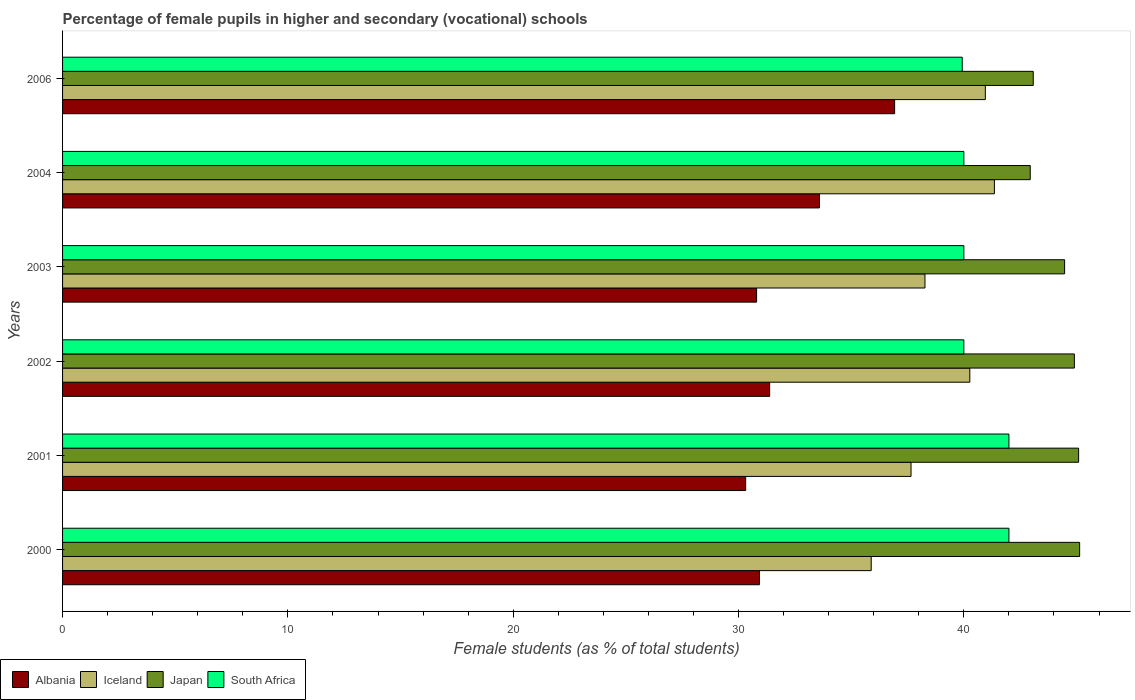How many groups of bars are there?
Ensure brevity in your answer.  6. How many bars are there on the 6th tick from the bottom?
Your response must be concise. 4. In how many cases, is the number of bars for a given year not equal to the number of legend labels?
Your answer should be very brief. 0. What is the percentage of female pupils in higher and secondary schools in Albania in 2002?
Your response must be concise. 31.38. Across all years, what is the maximum percentage of female pupils in higher and secondary schools in Albania?
Give a very brief answer. 36.93. Across all years, what is the minimum percentage of female pupils in higher and secondary schools in Iceland?
Ensure brevity in your answer.  35.89. What is the total percentage of female pupils in higher and secondary schools in Albania in the graph?
Provide a short and direct response. 193.95. What is the difference between the percentage of female pupils in higher and secondary schools in Albania in 2001 and that in 2002?
Keep it short and to the point. -1.06. What is the difference between the percentage of female pupils in higher and secondary schools in Albania in 2000 and the percentage of female pupils in higher and secondary schools in South Africa in 2002?
Your response must be concise. -9.07. What is the average percentage of female pupils in higher and secondary schools in Japan per year?
Make the answer very short. 44.27. In the year 2000, what is the difference between the percentage of female pupils in higher and secondary schools in South Africa and percentage of female pupils in higher and secondary schools in Iceland?
Provide a short and direct response. 6.11. In how many years, is the percentage of female pupils in higher and secondary schools in Iceland greater than 14 %?
Your answer should be very brief. 6. What is the ratio of the percentage of female pupils in higher and secondary schools in Albania in 2000 to that in 2004?
Ensure brevity in your answer.  0.92. What is the difference between the highest and the second highest percentage of female pupils in higher and secondary schools in Iceland?
Ensure brevity in your answer.  0.4. What is the difference between the highest and the lowest percentage of female pupils in higher and secondary schools in Japan?
Your answer should be very brief. 2.19. In how many years, is the percentage of female pupils in higher and secondary schools in Japan greater than the average percentage of female pupils in higher and secondary schools in Japan taken over all years?
Give a very brief answer. 4. Is it the case that in every year, the sum of the percentage of female pupils in higher and secondary schools in Japan and percentage of female pupils in higher and secondary schools in Iceland is greater than the sum of percentage of female pupils in higher and secondary schools in Albania and percentage of female pupils in higher and secondary schools in South Africa?
Your response must be concise. Yes. What does the 4th bar from the top in 2004 represents?
Keep it short and to the point. Albania. What does the 2nd bar from the bottom in 2002 represents?
Make the answer very short. Iceland. Is it the case that in every year, the sum of the percentage of female pupils in higher and secondary schools in Japan and percentage of female pupils in higher and secondary schools in Albania is greater than the percentage of female pupils in higher and secondary schools in Iceland?
Provide a short and direct response. Yes. Are all the bars in the graph horizontal?
Your answer should be compact. Yes. Where does the legend appear in the graph?
Ensure brevity in your answer.  Bottom left. How are the legend labels stacked?
Provide a succinct answer. Horizontal. What is the title of the graph?
Provide a succinct answer. Percentage of female pupils in higher and secondary (vocational) schools. What is the label or title of the X-axis?
Offer a very short reply. Female students (as % of total students). What is the Female students (as % of total students) of Albania in 2000?
Your answer should be compact. 30.93. What is the Female students (as % of total students) of Iceland in 2000?
Your response must be concise. 35.89. What is the Female students (as % of total students) in Japan in 2000?
Your answer should be very brief. 45.14. What is the Female students (as % of total students) of South Africa in 2000?
Keep it short and to the point. 42. What is the Female students (as % of total students) in Albania in 2001?
Offer a very short reply. 30.32. What is the Female students (as % of total students) of Iceland in 2001?
Provide a short and direct response. 37.66. What is the Female students (as % of total students) of Japan in 2001?
Make the answer very short. 45.09. What is the Female students (as % of total students) in South Africa in 2001?
Ensure brevity in your answer.  42. What is the Female students (as % of total students) in Albania in 2002?
Offer a terse response. 31.38. What is the Female students (as % of total students) in Iceland in 2002?
Your response must be concise. 40.26. What is the Female students (as % of total students) of Japan in 2002?
Offer a very short reply. 44.9. What is the Female students (as % of total students) of South Africa in 2002?
Ensure brevity in your answer.  40. What is the Female students (as % of total students) in Albania in 2003?
Your answer should be compact. 30.8. What is the Female students (as % of total students) of Iceland in 2003?
Provide a short and direct response. 38.27. What is the Female students (as % of total students) in Japan in 2003?
Provide a short and direct response. 44.47. What is the Female students (as % of total students) of South Africa in 2003?
Your answer should be very brief. 40. What is the Female students (as % of total students) in Albania in 2004?
Give a very brief answer. 33.59. What is the Female students (as % of total students) in Iceland in 2004?
Your response must be concise. 41.36. What is the Female students (as % of total students) in Japan in 2004?
Your answer should be compact. 42.95. What is the Female students (as % of total students) in South Africa in 2004?
Offer a terse response. 40. What is the Female students (as % of total students) of Albania in 2006?
Ensure brevity in your answer.  36.93. What is the Female students (as % of total students) of Iceland in 2006?
Your answer should be very brief. 40.95. What is the Female students (as % of total students) of Japan in 2006?
Offer a very short reply. 43.08. What is the Female students (as % of total students) in South Africa in 2006?
Give a very brief answer. 39.93. Across all years, what is the maximum Female students (as % of total students) of Albania?
Your answer should be very brief. 36.93. Across all years, what is the maximum Female students (as % of total students) of Iceland?
Offer a very short reply. 41.36. Across all years, what is the maximum Female students (as % of total students) of Japan?
Your response must be concise. 45.14. Across all years, what is the maximum Female students (as % of total students) of South Africa?
Offer a terse response. 42. Across all years, what is the minimum Female students (as % of total students) of Albania?
Keep it short and to the point. 30.32. Across all years, what is the minimum Female students (as % of total students) of Iceland?
Ensure brevity in your answer.  35.89. Across all years, what is the minimum Female students (as % of total students) in Japan?
Offer a very short reply. 42.95. Across all years, what is the minimum Female students (as % of total students) of South Africa?
Keep it short and to the point. 39.93. What is the total Female students (as % of total students) of Albania in the graph?
Offer a very short reply. 193.95. What is the total Female students (as % of total students) in Iceland in the graph?
Offer a terse response. 234.39. What is the total Female students (as % of total students) in Japan in the graph?
Give a very brief answer. 265.64. What is the total Female students (as % of total students) of South Africa in the graph?
Your response must be concise. 243.93. What is the difference between the Female students (as % of total students) of Albania in 2000 and that in 2001?
Give a very brief answer. 0.61. What is the difference between the Female students (as % of total students) in Iceland in 2000 and that in 2001?
Your response must be concise. -1.77. What is the difference between the Female students (as % of total students) in Japan in 2000 and that in 2001?
Your answer should be compact. 0.04. What is the difference between the Female students (as % of total students) of Albania in 2000 and that in 2002?
Your response must be concise. -0.45. What is the difference between the Female students (as % of total students) in Iceland in 2000 and that in 2002?
Provide a short and direct response. -4.38. What is the difference between the Female students (as % of total students) of Japan in 2000 and that in 2002?
Your answer should be compact. 0.23. What is the difference between the Female students (as % of total students) in South Africa in 2000 and that in 2002?
Ensure brevity in your answer.  2. What is the difference between the Female students (as % of total students) of Albania in 2000 and that in 2003?
Offer a terse response. 0.13. What is the difference between the Female students (as % of total students) of Iceland in 2000 and that in 2003?
Make the answer very short. -2.39. What is the difference between the Female students (as % of total students) of Japan in 2000 and that in 2003?
Keep it short and to the point. 0.67. What is the difference between the Female students (as % of total students) in South Africa in 2000 and that in 2003?
Provide a succinct answer. 2. What is the difference between the Female students (as % of total students) in Albania in 2000 and that in 2004?
Your answer should be compact. -2.66. What is the difference between the Female students (as % of total students) of Iceland in 2000 and that in 2004?
Make the answer very short. -5.47. What is the difference between the Female students (as % of total students) of Japan in 2000 and that in 2004?
Your response must be concise. 2.19. What is the difference between the Female students (as % of total students) of South Africa in 2000 and that in 2004?
Your answer should be compact. 2. What is the difference between the Female students (as % of total students) in Albania in 2000 and that in 2006?
Keep it short and to the point. -6. What is the difference between the Female students (as % of total students) of Iceland in 2000 and that in 2006?
Provide a succinct answer. -5.07. What is the difference between the Female students (as % of total students) of Japan in 2000 and that in 2006?
Provide a succinct answer. 2.06. What is the difference between the Female students (as % of total students) of South Africa in 2000 and that in 2006?
Offer a very short reply. 2.07. What is the difference between the Female students (as % of total students) of Albania in 2001 and that in 2002?
Your response must be concise. -1.06. What is the difference between the Female students (as % of total students) of Iceland in 2001 and that in 2002?
Give a very brief answer. -2.61. What is the difference between the Female students (as % of total students) in Japan in 2001 and that in 2002?
Provide a short and direct response. 0.19. What is the difference between the Female students (as % of total students) of South Africa in 2001 and that in 2002?
Your response must be concise. 2. What is the difference between the Female students (as % of total students) in Albania in 2001 and that in 2003?
Offer a terse response. -0.49. What is the difference between the Female students (as % of total students) in Iceland in 2001 and that in 2003?
Ensure brevity in your answer.  -0.62. What is the difference between the Female students (as % of total students) of Japan in 2001 and that in 2003?
Make the answer very short. 0.62. What is the difference between the Female students (as % of total students) in South Africa in 2001 and that in 2003?
Offer a terse response. 2. What is the difference between the Female students (as % of total students) in Albania in 2001 and that in 2004?
Provide a short and direct response. -3.28. What is the difference between the Female students (as % of total students) of Iceland in 2001 and that in 2004?
Make the answer very short. -3.7. What is the difference between the Female students (as % of total students) of Japan in 2001 and that in 2004?
Your response must be concise. 2.15. What is the difference between the Female students (as % of total students) in South Africa in 2001 and that in 2004?
Provide a succinct answer. 2. What is the difference between the Female students (as % of total students) in Albania in 2001 and that in 2006?
Offer a very short reply. -6.61. What is the difference between the Female students (as % of total students) of Iceland in 2001 and that in 2006?
Offer a very short reply. -3.3. What is the difference between the Female students (as % of total students) in Japan in 2001 and that in 2006?
Keep it short and to the point. 2.01. What is the difference between the Female students (as % of total students) of South Africa in 2001 and that in 2006?
Ensure brevity in your answer.  2.07. What is the difference between the Female students (as % of total students) in Albania in 2002 and that in 2003?
Your response must be concise. 0.58. What is the difference between the Female students (as % of total students) of Iceland in 2002 and that in 2003?
Your answer should be compact. 1.99. What is the difference between the Female students (as % of total students) of Japan in 2002 and that in 2003?
Offer a terse response. 0.43. What is the difference between the Female students (as % of total students) in South Africa in 2002 and that in 2003?
Offer a terse response. -0. What is the difference between the Female students (as % of total students) of Albania in 2002 and that in 2004?
Keep it short and to the point. -2.21. What is the difference between the Female students (as % of total students) in Iceland in 2002 and that in 2004?
Your response must be concise. -1.09. What is the difference between the Female students (as % of total students) of Japan in 2002 and that in 2004?
Keep it short and to the point. 1.96. What is the difference between the Female students (as % of total students) in South Africa in 2002 and that in 2004?
Your answer should be compact. -0. What is the difference between the Female students (as % of total students) of Albania in 2002 and that in 2006?
Provide a succinct answer. -5.55. What is the difference between the Female students (as % of total students) in Iceland in 2002 and that in 2006?
Ensure brevity in your answer.  -0.69. What is the difference between the Female students (as % of total students) in Japan in 2002 and that in 2006?
Your response must be concise. 1.82. What is the difference between the Female students (as % of total students) of South Africa in 2002 and that in 2006?
Give a very brief answer. 0.07. What is the difference between the Female students (as % of total students) in Albania in 2003 and that in 2004?
Your response must be concise. -2.79. What is the difference between the Female students (as % of total students) of Iceland in 2003 and that in 2004?
Your response must be concise. -3.08. What is the difference between the Female students (as % of total students) in Japan in 2003 and that in 2004?
Offer a very short reply. 1.52. What is the difference between the Female students (as % of total students) of Albania in 2003 and that in 2006?
Provide a short and direct response. -6.13. What is the difference between the Female students (as % of total students) of Iceland in 2003 and that in 2006?
Offer a very short reply. -2.68. What is the difference between the Female students (as % of total students) of Japan in 2003 and that in 2006?
Offer a terse response. 1.39. What is the difference between the Female students (as % of total students) in South Africa in 2003 and that in 2006?
Provide a succinct answer. 0.07. What is the difference between the Female students (as % of total students) of Albania in 2004 and that in 2006?
Offer a very short reply. -3.33. What is the difference between the Female students (as % of total students) of Iceland in 2004 and that in 2006?
Provide a short and direct response. 0.4. What is the difference between the Female students (as % of total students) of Japan in 2004 and that in 2006?
Ensure brevity in your answer.  -0.13. What is the difference between the Female students (as % of total students) in South Africa in 2004 and that in 2006?
Keep it short and to the point. 0.07. What is the difference between the Female students (as % of total students) of Albania in 2000 and the Female students (as % of total students) of Iceland in 2001?
Keep it short and to the point. -6.73. What is the difference between the Female students (as % of total students) of Albania in 2000 and the Female students (as % of total students) of Japan in 2001?
Make the answer very short. -14.17. What is the difference between the Female students (as % of total students) in Albania in 2000 and the Female students (as % of total students) in South Africa in 2001?
Provide a succinct answer. -11.07. What is the difference between the Female students (as % of total students) in Iceland in 2000 and the Female students (as % of total students) in Japan in 2001?
Offer a terse response. -9.21. What is the difference between the Female students (as % of total students) of Iceland in 2000 and the Female students (as % of total students) of South Africa in 2001?
Keep it short and to the point. -6.11. What is the difference between the Female students (as % of total students) of Japan in 2000 and the Female students (as % of total students) of South Africa in 2001?
Provide a succinct answer. 3.14. What is the difference between the Female students (as % of total students) of Albania in 2000 and the Female students (as % of total students) of Iceland in 2002?
Keep it short and to the point. -9.34. What is the difference between the Female students (as % of total students) in Albania in 2000 and the Female students (as % of total students) in Japan in 2002?
Your response must be concise. -13.98. What is the difference between the Female students (as % of total students) in Albania in 2000 and the Female students (as % of total students) in South Africa in 2002?
Make the answer very short. -9.07. What is the difference between the Female students (as % of total students) in Iceland in 2000 and the Female students (as % of total students) in Japan in 2002?
Offer a terse response. -9.02. What is the difference between the Female students (as % of total students) in Iceland in 2000 and the Female students (as % of total students) in South Africa in 2002?
Give a very brief answer. -4.11. What is the difference between the Female students (as % of total students) of Japan in 2000 and the Female students (as % of total students) of South Africa in 2002?
Keep it short and to the point. 5.14. What is the difference between the Female students (as % of total students) of Albania in 2000 and the Female students (as % of total students) of Iceland in 2003?
Give a very brief answer. -7.35. What is the difference between the Female students (as % of total students) in Albania in 2000 and the Female students (as % of total students) in Japan in 2003?
Give a very brief answer. -13.54. What is the difference between the Female students (as % of total students) in Albania in 2000 and the Female students (as % of total students) in South Africa in 2003?
Offer a very short reply. -9.07. What is the difference between the Female students (as % of total students) of Iceland in 2000 and the Female students (as % of total students) of Japan in 2003?
Provide a short and direct response. -8.58. What is the difference between the Female students (as % of total students) in Iceland in 2000 and the Female students (as % of total students) in South Africa in 2003?
Give a very brief answer. -4.11. What is the difference between the Female students (as % of total students) in Japan in 2000 and the Female students (as % of total students) in South Africa in 2003?
Keep it short and to the point. 5.14. What is the difference between the Female students (as % of total students) in Albania in 2000 and the Female students (as % of total students) in Iceland in 2004?
Make the answer very short. -10.43. What is the difference between the Female students (as % of total students) in Albania in 2000 and the Female students (as % of total students) in Japan in 2004?
Offer a terse response. -12.02. What is the difference between the Female students (as % of total students) in Albania in 2000 and the Female students (as % of total students) in South Africa in 2004?
Your answer should be compact. -9.07. What is the difference between the Female students (as % of total students) of Iceland in 2000 and the Female students (as % of total students) of Japan in 2004?
Your response must be concise. -7.06. What is the difference between the Female students (as % of total students) in Iceland in 2000 and the Female students (as % of total students) in South Africa in 2004?
Ensure brevity in your answer.  -4.11. What is the difference between the Female students (as % of total students) of Japan in 2000 and the Female students (as % of total students) of South Africa in 2004?
Offer a very short reply. 5.14. What is the difference between the Female students (as % of total students) in Albania in 2000 and the Female students (as % of total students) in Iceland in 2006?
Your response must be concise. -10.02. What is the difference between the Female students (as % of total students) of Albania in 2000 and the Female students (as % of total students) of Japan in 2006?
Offer a terse response. -12.15. What is the difference between the Female students (as % of total students) of Albania in 2000 and the Female students (as % of total students) of South Africa in 2006?
Your response must be concise. -9. What is the difference between the Female students (as % of total students) of Iceland in 2000 and the Female students (as % of total students) of Japan in 2006?
Provide a short and direct response. -7.19. What is the difference between the Female students (as % of total students) of Iceland in 2000 and the Female students (as % of total students) of South Africa in 2006?
Offer a terse response. -4.04. What is the difference between the Female students (as % of total students) in Japan in 2000 and the Female students (as % of total students) in South Africa in 2006?
Your answer should be very brief. 5.21. What is the difference between the Female students (as % of total students) of Albania in 2001 and the Female students (as % of total students) of Iceland in 2002?
Offer a very short reply. -9.95. What is the difference between the Female students (as % of total students) of Albania in 2001 and the Female students (as % of total students) of Japan in 2002?
Make the answer very short. -14.59. What is the difference between the Female students (as % of total students) of Albania in 2001 and the Female students (as % of total students) of South Africa in 2002?
Offer a very short reply. -9.68. What is the difference between the Female students (as % of total students) of Iceland in 2001 and the Female students (as % of total students) of Japan in 2002?
Ensure brevity in your answer.  -7.25. What is the difference between the Female students (as % of total students) in Iceland in 2001 and the Female students (as % of total students) in South Africa in 2002?
Keep it short and to the point. -2.34. What is the difference between the Female students (as % of total students) in Japan in 2001 and the Female students (as % of total students) in South Africa in 2002?
Your answer should be very brief. 5.09. What is the difference between the Female students (as % of total students) in Albania in 2001 and the Female students (as % of total students) in Iceland in 2003?
Your response must be concise. -7.96. What is the difference between the Female students (as % of total students) of Albania in 2001 and the Female students (as % of total students) of Japan in 2003?
Your answer should be very brief. -14.15. What is the difference between the Female students (as % of total students) of Albania in 2001 and the Female students (as % of total students) of South Africa in 2003?
Keep it short and to the point. -9.68. What is the difference between the Female students (as % of total students) of Iceland in 2001 and the Female students (as % of total students) of Japan in 2003?
Your answer should be compact. -6.82. What is the difference between the Female students (as % of total students) of Iceland in 2001 and the Female students (as % of total students) of South Africa in 2003?
Make the answer very short. -2.34. What is the difference between the Female students (as % of total students) of Japan in 2001 and the Female students (as % of total students) of South Africa in 2003?
Offer a very short reply. 5.09. What is the difference between the Female students (as % of total students) in Albania in 2001 and the Female students (as % of total students) in Iceland in 2004?
Offer a very short reply. -11.04. What is the difference between the Female students (as % of total students) of Albania in 2001 and the Female students (as % of total students) of Japan in 2004?
Give a very brief answer. -12.63. What is the difference between the Female students (as % of total students) of Albania in 2001 and the Female students (as % of total students) of South Africa in 2004?
Your answer should be compact. -9.68. What is the difference between the Female students (as % of total students) of Iceland in 2001 and the Female students (as % of total students) of Japan in 2004?
Provide a short and direct response. -5.29. What is the difference between the Female students (as % of total students) of Iceland in 2001 and the Female students (as % of total students) of South Africa in 2004?
Keep it short and to the point. -2.34. What is the difference between the Female students (as % of total students) in Japan in 2001 and the Female students (as % of total students) in South Africa in 2004?
Ensure brevity in your answer.  5.09. What is the difference between the Female students (as % of total students) of Albania in 2001 and the Female students (as % of total students) of Iceland in 2006?
Make the answer very short. -10.64. What is the difference between the Female students (as % of total students) in Albania in 2001 and the Female students (as % of total students) in Japan in 2006?
Provide a succinct answer. -12.76. What is the difference between the Female students (as % of total students) of Albania in 2001 and the Female students (as % of total students) of South Africa in 2006?
Your answer should be very brief. -9.61. What is the difference between the Female students (as % of total students) in Iceland in 2001 and the Female students (as % of total students) in Japan in 2006?
Your answer should be very brief. -5.42. What is the difference between the Female students (as % of total students) of Iceland in 2001 and the Female students (as % of total students) of South Africa in 2006?
Give a very brief answer. -2.27. What is the difference between the Female students (as % of total students) in Japan in 2001 and the Female students (as % of total students) in South Africa in 2006?
Give a very brief answer. 5.17. What is the difference between the Female students (as % of total students) in Albania in 2002 and the Female students (as % of total students) in Iceland in 2003?
Keep it short and to the point. -6.89. What is the difference between the Female students (as % of total students) of Albania in 2002 and the Female students (as % of total students) of Japan in 2003?
Provide a succinct answer. -13.09. What is the difference between the Female students (as % of total students) in Albania in 2002 and the Female students (as % of total students) in South Africa in 2003?
Your response must be concise. -8.62. What is the difference between the Female students (as % of total students) of Iceland in 2002 and the Female students (as % of total students) of Japan in 2003?
Provide a short and direct response. -4.21. What is the difference between the Female students (as % of total students) of Iceland in 2002 and the Female students (as % of total students) of South Africa in 2003?
Offer a very short reply. 0.26. What is the difference between the Female students (as % of total students) of Japan in 2002 and the Female students (as % of total students) of South Africa in 2003?
Ensure brevity in your answer.  4.9. What is the difference between the Female students (as % of total students) of Albania in 2002 and the Female students (as % of total students) of Iceland in 2004?
Offer a very short reply. -9.97. What is the difference between the Female students (as % of total students) in Albania in 2002 and the Female students (as % of total students) in Japan in 2004?
Keep it short and to the point. -11.57. What is the difference between the Female students (as % of total students) of Albania in 2002 and the Female students (as % of total students) of South Africa in 2004?
Your response must be concise. -8.62. What is the difference between the Female students (as % of total students) in Iceland in 2002 and the Female students (as % of total students) in Japan in 2004?
Offer a very short reply. -2.68. What is the difference between the Female students (as % of total students) in Iceland in 2002 and the Female students (as % of total students) in South Africa in 2004?
Ensure brevity in your answer.  0.26. What is the difference between the Female students (as % of total students) of Japan in 2002 and the Female students (as % of total students) of South Africa in 2004?
Provide a succinct answer. 4.9. What is the difference between the Female students (as % of total students) of Albania in 2002 and the Female students (as % of total students) of Iceland in 2006?
Your answer should be compact. -9.57. What is the difference between the Female students (as % of total students) in Albania in 2002 and the Female students (as % of total students) in Japan in 2006?
Your answer should be very brief. -11.7. What is the difference between the Female students (as % of total students) in Albania in 2002 and the Female students (as % of total students) in South Africa in 2006?
Your response must be concise. -8.55. What is the difference between the Female students (as % of total students) of Iceland in 2002 and the Female students (as % of total students) of Japan in 2006?
Provide a short and direct response. -2.82. What is the difference between the Female students (as % of total students) in Iceland in 2002 and the Female students (as % of total students) in South Africa in 2006?
Provide a short and direct response. 0.34. What is the difference between the Female students (as % of total students) in Japan in 2002 and the Female students (as % of total students) in South Africa in 2006?
Your answer should be very brief. 4.98. What is the difference between the Female students (as % of total students) in Albania in 2003 and the Female students (as % of total students) in Iceland in 2004?
Provide a short and direct response. -10.55. What is the difference between the Female students (as % of total students) in Albania in 2003 and the Female students (as % of total students) in Japan in 2004?
Make the answer very short. -12.15. What is the difference between the Female students (as % of total students) of Albania in 2003 and the Female students (as % of total students) of South Africa in 2004?
Offer a very short reply. -9.2. What is the difference between the Female students (as % of total students) of Iceland in 2003 and the Female students (as % of total students) of Japan in 2004?
Offer a terse response. -4.67. What is the difference between the Female students (as % of total students) of Iceland in 2003 and the Female students (as % of total students) of South Africa in 2004?
Your answer should be very brief. -1.73. What is the difference between the Female students (as % of total students) of Japan in 2003 and the Female students (as % of total students) of South Africa in 2004?
Offer a very short reply. 4.47. What is the difference between the Female students (as % of total students) in Albania in 2003 and the Female students (as % of total students) in Iceland in 2006?
Ensure brevity in your answer.  -10.15. What is the difference between the Female students (as % of total students) in Albania in 2003 and the Female students (as % of total students) in Japan in 2006?
Provide a short and direct response. -12.28. What is the difference between the Female students (as % of total students) in Albania in 2003 and the Female students (as % of total students) in South Africa in 2006?
Your response must be concise. -9.13. What is the difference between the Female students (as % of total students) of Iceland in 2003 and the Female students (as % of total students) of Japan in 2006?
Offer a terse response. -4.81. What is the difference between the Female students (as % of total students) of Iceland in 2003 and the Female students (as % of total students) of South Africa in 2006?
Offer a very short reply. -1.65. What is the difference between the Female students (as % of total students) in Japan in 2003 and the Female students (as % of total students) in South Africa in 2006?
Make the answer very short. 4.54. What is the difference between the Female students (as % of total students) of Albania in 2004 and the Female students (as % of total students) of Iceland in 2006?
Keep it short and to the point. -7.36. What is the difference between the Female students (as % of total students) in Albania in 2004 and the Female students (as % of total students) in Japan in 2006?
Keep it short and to the point. -9.49. What is the difference between the Female students (as % of total students) of Albania in 2004 and the Female students (as % of total students) of South Africa in 2006?
Ensure brevity in your answer.  -6.34. What is the difference between the Female students (as % of total students) of Iceland in 2004 and the Female students (as % of total students) of Japan in 2006?
Ensure brevity in your answer.  -1.72. What is the difference between the Female students (as % of total students) in Iceland in 2004 and the Female students (as % of total students) in South Africa in 2006?
Your response must be concise. 1.43. What is the difference between the Female students (as % of total students) of Japan in 2004 and the Female students (as % of total students) of South Africa in 2006?
Your answer should be very brief. 3.02. What is the average Female students (as % of total students) of Albania per year?
Provide a succinct answer. 32.32. What is the average Female students (as % of total students) in Iceland per year?
Keep it short and to the point. 39.07. What is the average Female students (as % of total students) in Japan per year?
Make the answer very short. 44.27. What is the average Female students (as % of total students) in South Africa per year?
Your answer should be very brief. 40.65. In the year 2000, what is the difference between the Female students (as % of total students) in Albania and Female students (as % of total students) in Iceland?
Your response must be concise. -4.96. In the year 2000, what is the difference between the Female students (as % of total students) of Albania and Female students (as % of total students) of Japan?
Provide a succinct answer. -14.21. In the year 2000, what is the difference between the Female students (as % of total students) of Albania and Female students (as % of total students) of South Africa?
Offer a very short reply. -11.07. In the year 2000, what is the difference between the Female students (as % of total students) in Iceland and Female students (as % of total students) in Japan?
Provide a short and direct response. -9.25. In the year 2000, what is the difference between the Female students (as % of total students) of Iceland and Female students (as % of total students) of South Africa?
Your response must be concise. -6.11. In the year 2000, what is the difference between the Female students (as % of total students) of Japan and Female students (as % of total students) of South Africa?
Provide a short and direct response. 3.14. In the year 2001, what is the difference between the Female students (as % of total students) in Albania and Female students (as % of total students) in Iceland?
Your response must be concise. -7.34. In the year 2001, what is the difference between the Female students (as % of total students) of Albania and Female students (as % of total students) of Japan?
Ensure brevity in your answer.  -14.78. In the year 2001, what is the difference between the Female students (as % of total students) in Albania and Female students (as % of total students) in South Africa?
Provide a succinct answer. -11.68. In the year 2001, what is the difference between the Female students (as % of total students) of Iceland and Female students (as % of total students) of Japan?
Keep it short and to the point. -7.44. In the year 2001, what is the difference between the Female students (as % of total students) of Iceland and Female students (as % of total students) of South Africa?
Provide a succinct answer. -4.34. In the year 2001, what is the difference between the Female students (as % of total students) of Japan and Female students (as % of total students) of South Africa?
Provide a short and direct response. 3.09. In the year 2002, what is the difference between the Female students (as % of total students) in Albania and Female students (as % of total students) in Iceland?
Make the answer very short. -8.88. In the year 2002, what is the difference between the Female students (as % of total students) in Albania and Female students (as % of total students) in Japan?
Provide a succinct answer. -13.52. In the year 2002, what is the difference between the Female students (as % of total students) of Albania and Female students (as % of total students) of South Africa?
Make the answer very short. -8.62. In the year 2002, what is the difference between the Female students (as % of total students) in Iceland and Female students (as % of total students) in Japan?
Give a very brief answer. -4.64. In the year 2002, what is the difference between the Female students (as % of total students) of Iceland and Female students (as % of total students) of South Africa?
Provide a short and direct response. 0.26. In the year 2002, what is the difference between the Female students (as % of total students) in Japan and Female students (as % of total students) in South Africa?
Make the answer very short. 4.9. In the year 2003, what is the difference between the Female students (as % of total students) of Albania and Female students (as % of total students) of Iceland?
Offer a terse response. -7.47. In the year 2003, what is the difference between the Female students (as % of total students) in Albania and Female students (as % of total students) in Japan?
Offer a terse response. -13.67. In the year 2003, what is the difference between the Female students (as % of total students) in Albania and Female students (as % of total students) in South Africa?
Provide a short and direct response. -9.2. In the year 2003, what is the difference between the Female students (as % of total students) of Iceland and Female students (as % of total students) of Japan?
Provide a succinct answer. -6.2. In the year 2003, what is the difference between the Female students (as % of total students) of Iceland and Female students (as % of total students) of South Africa?
Your response must be concise. -1.73. In the year 2003, what is the difference between the Female students (as % of total students) in Japan and Female students (as % of total students) in South Africa?
Offer a terse response. 4.47. In the year 2004, what is the difference between the Female students (as % of total students) in Albania and Female students (as % of total students) in Iceland?
Keep it short and to the point. -7.76. In the year 2004, what is the difference between the Female students (as % of total students) of Albania and Female students (as % of total students) of Japan?
Your answer should be compact. -9.35. In the year 2004, what is the difference between the Female students (as % of total students) in Albania and Female students (as % of total students) in South Africa?
Your response must be concise. -6.41. In the year 2004, what is the difference between the Female students (as % of total students) of Iceland and Female students (as % of total students) of Japan?
Your answer should be compact. -1.59. In the year 2004, what is the difference between the Female students (as % of total students) in Iceland and Female students (as % of total students) in South Africa?
Offer a terse response. 1.36. In the year 2004, what is the difference between the Female students (as % of total students) of Japan and Female students (as % of total students) of South Africa?
Your response must be concise. 2.95. In the year 2006, what is the difference between the Female students (as % of total students) in Albania and Female students (as % of total students) in Iceland?
Offer a terse response. -4.03. In the year 2006, what is the difference between the Female students (as % of total students) of Albania and Female students (as % of total students) of Japan?
Your answer should be compact. -6.15. In the year 2006, what is the difference between the Female students (as % of total students) of Albania and Female students (as % of total students) of South Africa?
Make the answer very short. -3. In the year 2006, what is the difference between the Female students (as % of total students) of Iceland and Female students (as % of total students) of Japan?
Keep it short and to the point. -2.13. In the year 2006, what is the difference between the Female students (as % of total students) of Iceland and Female students (as % of total students) of South Africa?
Offer a terse response. 1.03. In the year 2006, what is the difference between the Female students (as % of total students) of Japan and Female students (as % of total students) of South Africa?
Offer a very short reply. 3.15. What is the ratio of the Female students (as % of total students) of Albania in 2000 to that in 2001?
Your answer should be very brief. 1.02. What is the ratio of the Female students (as % of total students) in Iceland in 2000 to that in 2001?
Provide a short and direct response. 0.95. What is the ratio of the Female students (as % of total students) in Albania in 2000 to that in 2002?
Provide a short and direct response. 0.99. What is the ratio of the Female students (as % of total students) of Iceland in 2000 to that in 2002?
Your response must be concise. 0.89. What is the ratio of the Female students (as % of total students) of Albania in 2000 to that in 2003?
Make the answer very short. 1. What is the ratio of the Female students (as % of total students) of Iceland in 2000 to that in 2003?
Ensure brevity in your answer.  0.94. What is the ratio of the Female students (as % of total students) in Japan in 2000 to that in 2003?
Ensure brevity in your answer.  1.01. What is the ratio of the Female students (as % of total students) of South Africa in 2000 to that in 2003?
Make the answer very short. 1.05. What is the ratio of the Female students (as % of total students) of Albania in 2000 to that in 2004?
Your response must be concise. 0.92. What is the ratio of the Female students (as % of total students) of Iceland in 2000 to that in 2004?
Offer a very short reply. 0.87. What is the ratio of the Female students (as % of total students) in Japan in 2000 to that in 2004?
Offer a very short reply. 1.05. What is the ratio of the Female students (as % of total students) in South Africa in 2000 to that in 2004?
Provide a short and direct response. 1.05. What is the ratio of the Female students (as % of total students) of Albania in 2000 to that in 2006?
Offer a terse response. 0.84. What is the ratio of the Female students (as % of total students) in Iceland in 2000 to that in 2006?
Keep it short and to the point. 0.88. What is the ratio of the Female students (as % of total students) in Japan in 2000 to that in 2006?
Offer a very short reply. 1.05. What is the ratio of the Female students (as % of total students) of South Africa in 2000 to that in 2006?
Offer a terse response. 1.05. What is the ratio of the Female students (as % of total students) in Albania in 2001 to that in 2002?
Your answer should be very brief. 0.97. What is the ratio of the Female students (as % of total students) in Iceland in 2001 to that in 2002?
Provide a short and direct response. 0.94. What is the ratio of the Female students (as % of total students) in South Africa in 2001 to that in 2002?
Your answer should be compact. 1.05. What is the ratio of the Female students (as % of total students) of Albania in 2001 to that in 2003?
Your answer should be very brief. 0.98. What is the ratio of the Female students (as % of total students) of Iceland in 2001 to that in 2003?
Keep it short and to the point. 0.98. What is the ratio of the Female students (as % of total students) in Japan in 2001 to that in 2003?
Provide a succinct answer. 1.01. What is the ratio of the Female students (as % of total students) of South Africa in 2001 to that in 2003?
Provide a succinct answer. 1.05. What is the ratio of the Female students (as % of total students) of Albania in 2001 to that in 2004?
Give a very brief answer. 0.9. What is the ratio of the Female students (as % of total students) of Iceland in 2001 to that in 2004?
Your answer should be compact. 0.91. What is the ratio of the Female students (as % of total students) in Japan in 2001 to that in 2004?
Ensure brevity in your answer.  1.05. What is the ratio of the Female students (as % of total students) of Albania in 2001 to that in 2006?
Keep it short and to the point. 0.82. What is the ratio of the Female students (as % of total students) of Iceland in 2001 to that in 2006?
Your answer should be very brief. 0.92. What is the ratio of the Female students (as % of total students) in Japan in 2001 to that in 2006?
Provide a succinct answer. 1.05. What is the ratio of the Female students (as % of total students) in South Africa in 2001 to that in 2006?
Offer a very short reply. 1.05. What is the ratio of the Female students (as % of total students) of Albania in 2002 to that in 2003?
Offer a very short reply. 1.02. What is the ratio of the Female students (as % of total students) of Iceland in 2002 to that in 2003?
Your answer should be compact. 1.05. What is the ratio of the Female students (as % of total students) of Japan in 2002 to that in 2003?
Make the answer very short. 1.01. What is the ratio of the Female students (as % of total students) of Albania in 2002 to that in 2004?
Your answer should be compact. 0.93. What is the ratio of the Female students (as % of total students) of Iceland in 2002 to that in 2004?
Provide a short and direct response. 0.97. What is the ratio of the Female students (as % of total students) of Japan in 2002 to that in 2004?
Your answer should be compact. 1.05. What is the ratio of the Female students (as % of total students) in Albania in 2002 to that in 2006?
Offer a terse response. 0.85. What is the ratio of the Female students (as % of total students) of Iceland in 2002 to that in 2006?
Give a very brief answer. 0.98. What is the ratio of the Female students (as % of total students) of Japan in 2002 to that in 2006?
Provide a short and direct response. 1.04. What is the ratio of the Female students (as % of total students) of Albania in 2003 to that in 2004?
Your response must be concise. 0.92. What is the ratio of the Female students (as % of total students) of Iceland in 2003 to that in 2004?
Your response must be concise. 0.93. What is the ratio of the Female students (as % of total students) in Japan in 2003 to that in 2004?
Offer a terse response. 1.04. What is the ratio of the Female students (as % of total students) of Albania in 2003 to that in 2006?
Offer a terse response. 0.83. What is the ratio of the Female students (as % of total students) in Iceland in 2003 to that in 2006?
Give a very brief answer. 0.93. What is the ratio of the Female students (as % of total students) of Japan in 2003 to that in 2006?
Offer a very short reply. 1.03. What is the ratio of the Female students (as % of total students) of South Africa in 2003 to that in 2006?
Provide a succinct answer. 1. What is the ratio of the Female students (as % of total students) in Albania in 2004 to that in 2006?
Your response must be concise. 0.91. What is the ratio of the Female students (as % of total students) of Iceland in 2004 to that in 2006?
Provide a succinct answer. 1.01. What is the ratio of the Female students (as % of total students) of South Africa in 2004 to that in 2006?
Ensure brevity in your answer.  1. What is the difference between the highest and the second highest Female students (as % of total students) in Albania?
Provide a short and direct response. 3.33. What is the difference between the highest and the second highest Female students (as % of total students) in Iceland?
Offer a very short reply. 0.4. What is the difference between the highest and the second highest Female students (as % of total students) of Japan?
Your answer should be very brief. 0.04. What is the difference between the highest and the lowest Female students (as % of total students) in Albania?
Ensure brevity in your answer.  6.61. What is the difference between the highest and the lowest Female students (as % of total students) in Iceland?
Give a very brief answer. 5.47. What is the difference between the highest and the lowest Female students (as % of total students) of Japan?
Give a very brief answer. 2.19. What is the difference between the highest and the lowest Female students (as % of total students) in South Africa?
Your response must be concise. 2.07. 